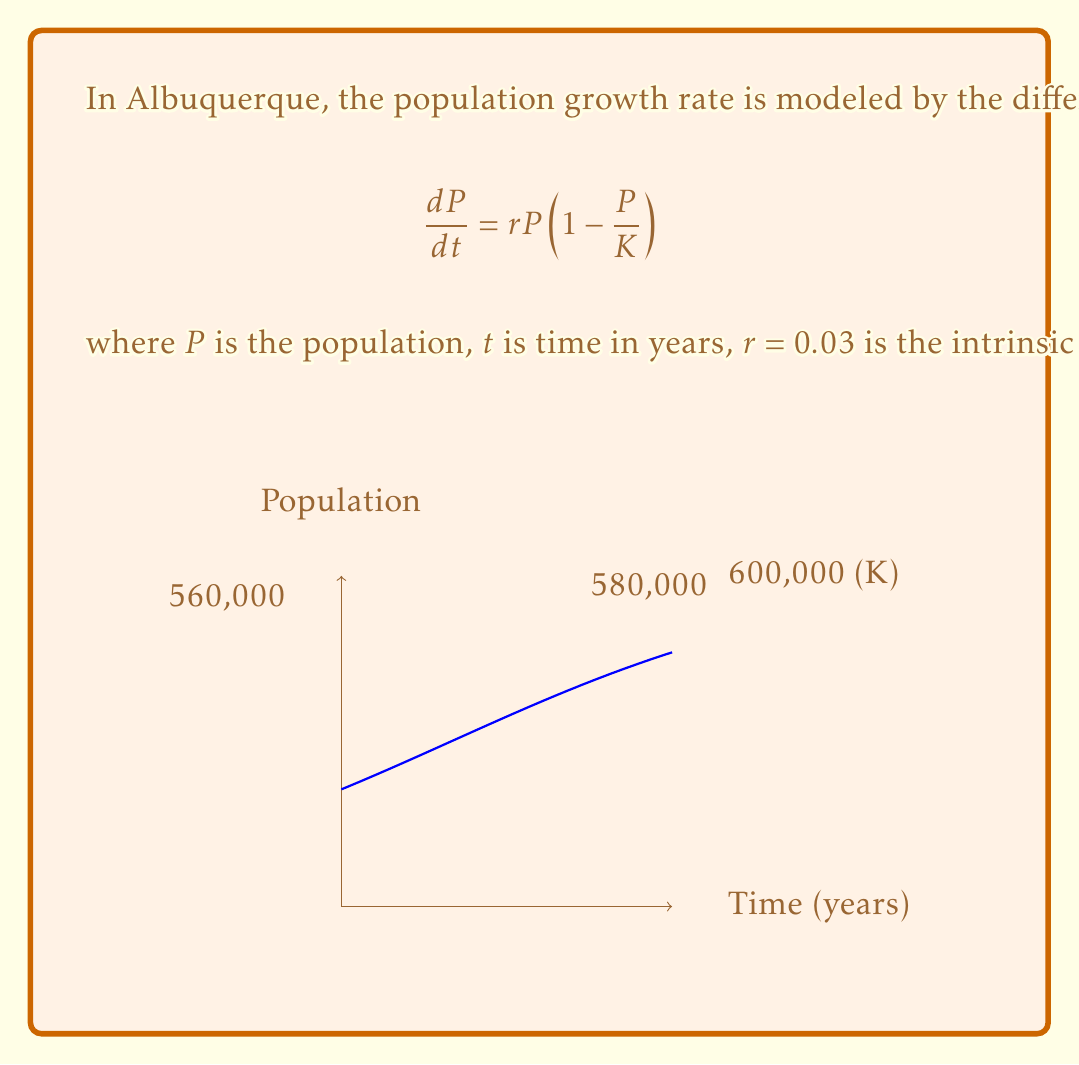Can you solve this math problem? To solve this problem, we'll use the logistic growth model:

1) The differential equation is separable. Rearranging it:
   $$\frac{dP}{P(1-P/K)} = rdt$$

2) Integrating both sides:
   $$\int \frac{dP}{P(1-P/K)} = \int rdt$$

3) The left side integrates to:
   $$-\ln|1-P/K| = rt + C$$

4) Solving for $P$:
   $$P = \frac{K}{1 + Ae^{-rt}}$$
   where $A$ is a constant determined by initial conditions.

5) Using the initial condition $P(0) = 560,000$:
   $$560,000 = \frac{600,000}{1 + A}$$
   $$A = \frac{600,000}{560,000} - 1 = 0.0714$$

6) Now we have the specific solution:
   $$P = \frac{600,000}{1 + 0.0714e^{-0.03t}}$$

7) To find when $P = 580,000$, solve:
   $$580,000 = \frac{600,000}{1 + 0.0714e^{-0.03t}}$$

8) Solving for $t$:
   $$t = -\frac{1}{0.03}\ln\left(\frac{600,000-580,000}{580,000 \cdot 0.0714}\right) \approx 13.86$$

Therefore, it will take approximately 13.86 years for the population to reach 580,000.
Answer: 13.86 years 